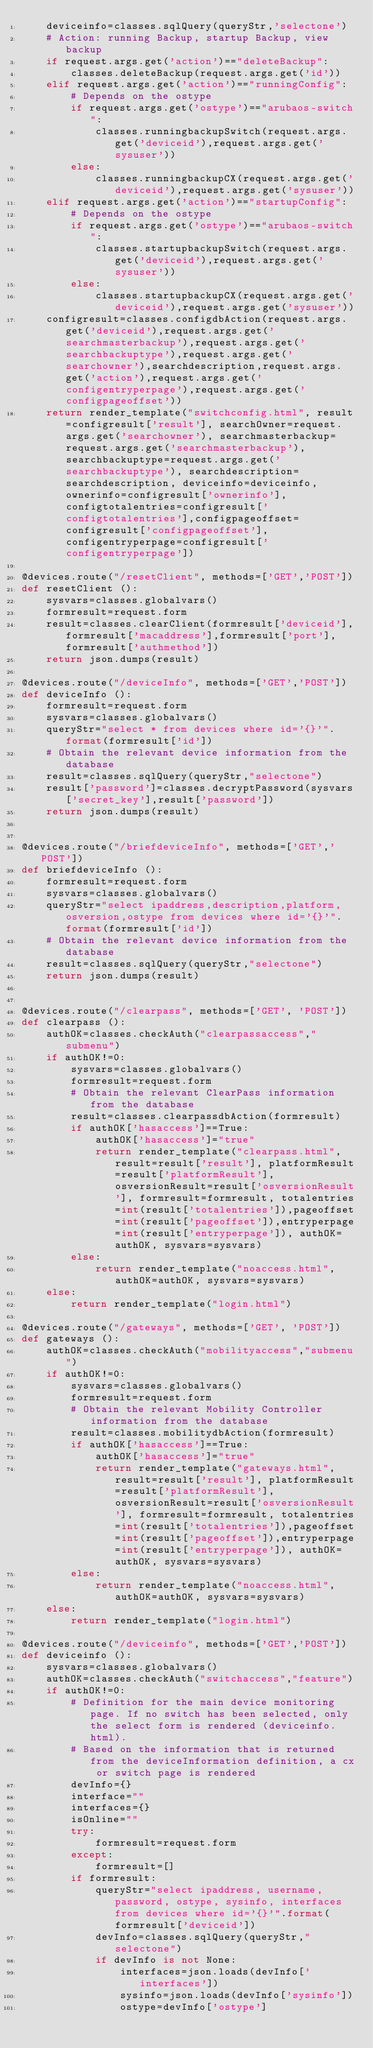<code> <loc_0><loc_0><loc_500><loc_500><_Python_>    deviceinfo=classes.sqlQuery(queryStr,'selectone')
    # Action: running Backup, startup Backup, view backup
    if request.args.get('action')=="deleteBackup":
        classes.deleteBackup(request.args.get('id'))
    elif request.args.get('action')=="runningConfig":
        # Depends on the ostype
        if request.args.get('ostype')=="arubaos-switch":
            classes.runningbackupSwitch(request.args.get('deviceid'),request.args.get('sysuser'))
        else:
            classes.runningbackupCX(request.args.get('deviceid'),request.args.get('sysuser'))
    elif request.args.get('action')=="startupConfig":
        # Depends on the ostype
        if request.args.get('ostype')=="arubaos-switch":
            classes.startupbackupSwitch(request.args.get('deviceid'),request.args.get('sysuser'))
        else:
            classes.startupbackupCX(request.args.get('deviceid'),request.args.get('sysuser'))
    configresult=classes.configdbAction(request.args.get('deviceid'),request.args.get('searchmasterbackup'),request.args.get('searchbackuptype'),request.args.get('searchowner'),searchdescription,request.args.get('action'),request.args.get('configentryperpage'),request.args.get('configpageoffset'))
    return render_template("switchconfig.html", result=configresult['result'], searchOwner=request.args.get('searchowner'), searchmasterbackup=request.args.get('searchmasterbackup'), searchbackuptype=request.args.get('searchbackuptype'), searchdescription=searchdescription, deviceinfo=deviceinfo, ownerinfo=configresult['ownerinfo'], configtotalentries=configresult['configtotalentries'],configpageoffset=configresult['configpageoffset'],configentryperpage=configresult['configentryperpage'])

@devices.route("/resetClient", methods=['GET','POST'])
def resetClient ():
    sysvars=classes.globalvars()
    formresult=request.form
    result=classes.clearClient(formresult['deviceid'],formresult['macaddress'],formresult['port'],formresult['authmethod'])
    return json.dumps(result)

@devices.route("/deviceInfo", methods=['GET','POST'])
def deviceInfo ():
    formresult=request.form
    sysvars=classes.globalvars()
    queryStr="select * from devices where id='{}'".format(formresult['id'])
    # Obtain the relevant device information from the database
    result=classes.sqlQuery(queryStr,"selectone")
    result['password']=classes.decryptPassword(sysvars['secret_key'],result['password'])
    return json.dumps(result)


@devices.route("/briefdeviceInfo", methods=['GET','POST'])
def briefdeviceInfo ():
    formresult=request.form
    sysvars=classes.globalvars()
    queryStr="select ipaddress,description,platform, osversion,ostype from devices where id='{}'".format(formresult['id'])
    # Obtain the relevant device information from the database
    result=classes.sqlQuery(queryStr,"selectone")
    return json.dumps(result)


@devices.route("/clearpass", methods=['GET', 'POST'])
def clearpass ():
    authOK=classes.checkAuth("clearpassaccess","submenu")
    if authOK!=0:
        sysvars=classes.globalvars()
        formresult=request.form
        # Obtain the relevant ClearPass information from the database
        result=classes.clearpassdbAction(formresult)
        if authOK['hasaccess']==True:
            authOK['hasaccess']="true"
            return render_template("clearpass.html",result=result['result'], platformResult=result['platformResult'],osversionResult=result['osversionResult'], formresult=formresult, totalentries=int(result['totalentries']),pageoffset=int(result['pageoffset']),entryperpage=int(result['entryperpage']), authOK=authOK, sysvars=sysvars)
        else:
            return render_template("noaccess.html",authOK=authOK, sysvars=sysvars)
    else:
        return render_template("login.html")

@devices.route("/gateways", methods=['GET', 'POST'])
def gateways ():
    authOK=classes.checkAuth("mobilityaccess","submenu")
    if authOK!=0:
        sysvars=classes.globalvars()
        formresult=request.form
        # Obtain the relevant Mobility Controller information from the database
        result=classes.mobilitydbAction(formresult)
        if authOK['hasaccess']==True:
            authOK['hasaccess']="true"
            return render_template("gateways.html",result=result['result'], platformResult=result['platformResult'],osversionResult=result['osversionResult'], formresult=formresult, totalentries=int(result['totalentries']),pageoffset=int(result['pageoffset']),entryperpage=int(result['entryperpage']), authOK=authOK, sysvars=sysvars)
        else:
            return render_template("noaccess.html",authOK=authOK, sysvars=sysvars)
    else:
        return render_template("login.html")

@devices.route("/deviceinfo", methods=['GET','POST'])
def deviceinfo ():
    sysvars=classes.globalvars()
    authOK=classes.checkAuth("switchaccess","feature")
    if authOK!=0:
        # Definition for the main device monitoring page. If no switch has been selected, only the select form is rendered (deviceinfo.html). 
        # Based on the information that is returned from the deviceInformation definition, a cx or switch page is rendered
        devInfo={}
        interface=""
        interfaces={}
        isOnline=""
        try:
            formresult=request.form
        except:
            formresult=[]
        if formresult:
            queryStr="select ipaddress, username, password, ostype, sysinfo, interfaces from devices where id='{}'".format(formresult['deviceid'])
            devInfo=classes.sqlQuery(queryStr,"selectone")
            if devInfo is not None:
                interfaces=json.loads(devInfo['interfaces'])
                sysinfo=json.loads(devInfo['sysinfo'])
                ostype=devInfo['ostype']</code> 